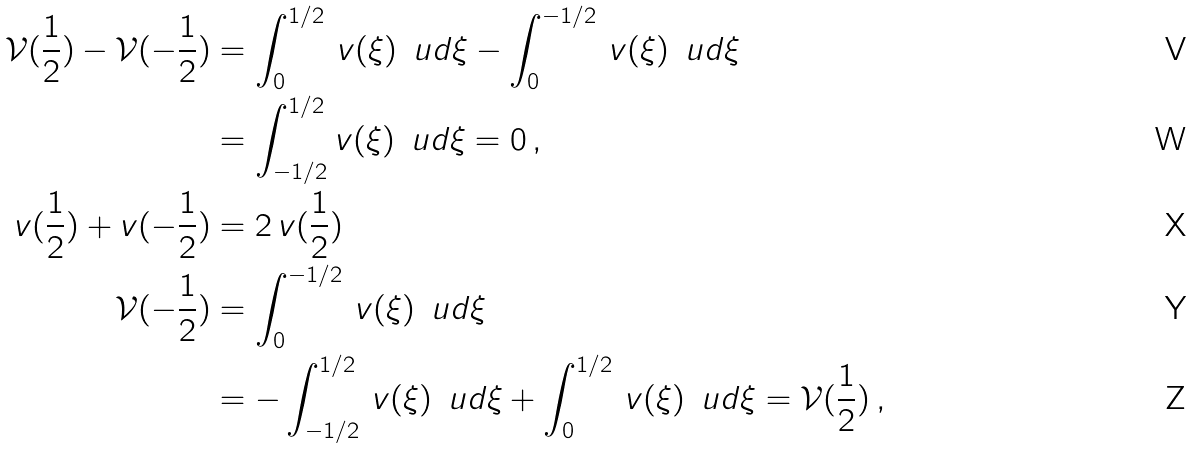<formula> <loc_0><loc_0><loc_500><loc_500>\mathcal { V } ( \frac { 1 } { 2 } ) - \mathcal { V } ( - \frac { 1 } { 2 } ) & = \int _ { 0 } ^ { 1 / 2 } \, v ( \xi ) \, \ u d \xi - \int _ { 0 } ^ { - 1 / 2 } \, v ( \xi ) \, \ u d \xi \\ & = \int _ { - 1 / 2 } ^ { 1 / 2 } v ( \xi ) \, \ u d \xi = 0 \, , \\ v ( \frac { 1 } { 2 } ) + v ( - \frac { 1 } { 2 } ) & = 2 \, v ( \frac { 1 } { 2 } ) \\ \mathcal { V } ( - \frac { 1 } { 2 } ) & = \int _ { 0 } ^ { - 1 / 2 } \, v ( \xi ) \, \ u d \xi \\ & = - \int _ { - 1 / 2 } ^ { 1 / 2 } \, v ( \xi ) \, \ u d \xi + \int _ { 0 } ^ { 1 / 2 } \, v ( \xi ) \, \ u d \xi = \mathcal { V } ( \frac { 1 } { 2 } ) \, ,</formula> 